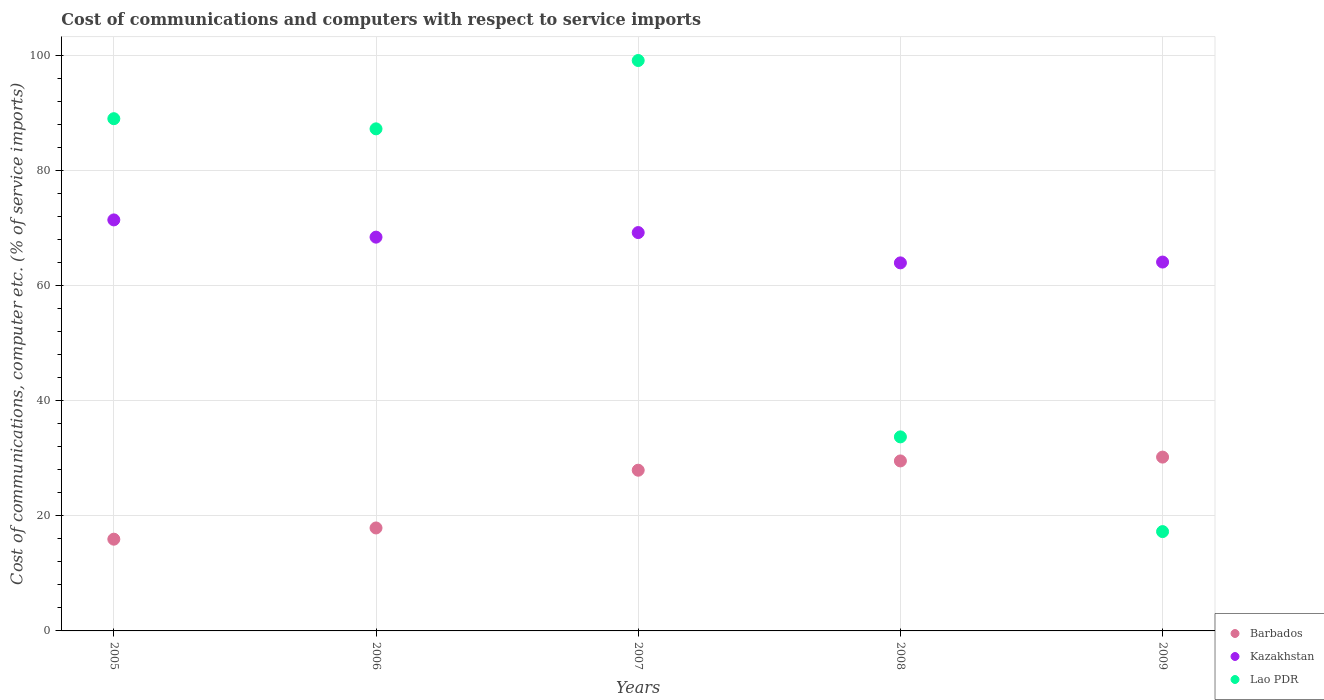Is the number of dotlines equal to the number of legend labels?
Your answer should be compact. Yes. What is the cost of communications and computers in Barbados in 2007?
Your answer should be compact. 27.93. Across all years, what is the maximum cost of communications and computers in Barbados?
Ensure brevity in your answer.  30.21. Across all years, what is the minimum cost of communications and computers in Barbados?
Offer a terse response. 15.94. In which year was the cost of communications and computers in Lao PDR maximum?
Provide a short and direct response. 2007. In which year was the cost of communications and computers in Lao PDR minimum?
Ensure brevity in your answer.  2009. What is the total cost of communications and computers in Lao PDR in the graph?
Your answer should be compact. 326.38. What is the difference between the cost of communications and computers in Kazakhstan in 2005 and that in 2006?
Offer a terse response. 3. What is the difference between the cost of communications and computers in Lao PDR in 2005 and the cost of communications and computers in Kazakhstan in 2007?
Your answer should be compact. 19.79. What is the average cost of communications and computers in Kazakhstan per year?
Your answer should be very brief. 67.43. In the year 2009, what is the difference between the cost of communications and computers in Kazakhstan and cost of communications and computers in Lao PDR?
Make the answer very short. 46.84. In how many years, is the cost of communications and computers in Barbados greater than 44 %?
Ensure brevity in your answer.  0. What is the ratio of the cost of communications and computers in Lao PDR in 2006 to that in 2009?
Ensure brevity in your answer.  5.05. What is the difference between the highest and the second highest cost of communications and computers in Lao PDR?
Give a very brief answer. 10.11. What is the difference between the highest and the lowest cost of communications and computers in Barbados?
Keep it short and to the point. 14.26. In how many years, is the cost of communications and computers in Kazakhstan greater than the average cost of communications and computers in Kazakhstan taken over all years?
Make the answer very short. 3. Is the sum of the cost of communications and computers in Lao PDR in 2006 and 2008 greater than the maximum cost of communications and computers in Barbados across all years?
Ensure brevity in your answer.  Yes. Is it the case that in every year, the sum of the cost of communications and computers in Kazakhstan and cost of communications and computers in Lao PDR  is greater than the cost of communications and computers in Barbados?
Make the answer very short. Yes. Is the cost of communications and computers in Kazakhstan strictly greater than the cost of communications and computers in Lao PDR over the years?
Your response must be concise. No. What is the difference between two consecutive major ticks on the Y-axis?
Give a very brief answer. 20. Does the graph contain grids?
Offer a terse response. Yes. How are the legend labels stacked?
Offer a terse response. Vertical. What is the title of the graph?
Provide a succinct answer. Cost of communications and computers with respect to service imports. Does "Germany" appear as one of the legend labels in the graph?
Keep it short and to the point. No. What is the label or title of the Y-axis?
Your answer should be compact. Cost of communications, computer etc. (% of service imports). What is the Cost of communications, computer etc. (% of service imports) of Barbados in 2005?
Provide a succinct answer. 15.94. What is the Cost of communications, computer etc. (% of service imports) of Kazakhstan in 2005?
Give a very brief answer. 71.43. What is the Cost of communications, computer etc. (% of service imports) of Lao PDR in 2005?
Offer a terse response. 89.02. What is the Cost of communications, computer etc. (% of service imports) of Barbados in 2006?
Provide a short and direct response. 17.89. What is the Cost of communications, computer etc. (% of service imports) in Kazakhstan in 2006?
Provide a succinct answer. 68.43. What is the Cost of communications, computer etc. (% of service imports) of Lao PDR in 2006?
Offer a terse response. 87.25. What is the Cost of communications, computer etc. (% of service imports) in Barbados in 2007?
Your answer should be very brief. 27.93. What is the Cost of communications, computer etc. (% of service imports) in Kazakhstan in 2007?
Keep it short and to the point. 69.23. What is the Cost of communications, computer etc. (% of service imports) in Lao PDR in 2007?
Keep it short and to the point. 99.13. What is the Cost of communications, computer etc. (% of service imports) of Barbados in 2008?
Offer a very short reply. 29.54. What is the Cost of communications, computer etc. (% of service imports) of Kazakhstan in 2008?
Make the answer very short. 63.96. What is the Cost of communications, computer etc. (% of service imports) in Lao PDR in 2008?
Provide a succinct answer. 33.72. What is the Cost of communications, computer etc. (% of service imports) of Barbados in 2009?
Offer a terse response. 30.21. What is the Cost of communications, computer etc. (% of service imports) of Kazakhstan in 2009?
Give a very brief answer. 64.1. What is the Cost of communications, computer etc. (% of service imports) of Lao PDR in 2009?
Offer a very short reply. 17.26. Across all years, what is the maximum Cost of communications, computer etc. (% of service imports) of Barbados?
Give a very brief answer. 30.21. Across all years, what is the maximum Cost of communications, computer etc. (% of service imports) in Kazakhstan?
Ensure brevity in your answer.  71.43. Across all years, what is the maximum Cost of communications, computer etc. (% of service imports) of Lao PDR?
Ensure brevity in your answer.  99.13. Across all years, what is the minimum Cost of communications, computer etc. (% of service imports) of Barbados?
Give a very brief answer. 15.94. Across all years, what is the minimum Cost of communications, computer etc. (% of service imports) of Kazakhstan?
Offer a very short reply. 63.96. Across all years, what is the minimum Cost of communications, computer etc. (% of service imports) in Lao PDR?
Offer a terse response. 17.26. What is the total Cost of communications, computer etc. (% of service imports) in Barbados in the graph?
Make the answer very short. 121.51. What is the total Cost of communications, computer etc. (% of service imports) of Kazakhstan in the graph?
Ensure brevity in your answer.  337.15. What is the total Cost of communications, computer etc. (% of service imports) of Lao PDR in the graph?
Keep it short and to the point. 326.38. What is the difference between the Cost of communications, computer etc. (% of service imports) of Barbados in 2005 and that in 2006?
Provide a short and direct response. -1.95. What is the difference between the Cost of communications, computer etc. (% of service imports) of Kazakhstan in 2005 and that in 2006?
Your answer should be very brief. 3. What is the difference between the Cost of communications, computer etc. (% of service imports) of Lao PDR in 2005 and that in 2006?
Make the answer very short. 1.77. What is the difference between the Cost of communications, computer etc. (% of service imports) in Barbados in 2005 and that in 2007?
Your answer should be very brief. -11.99. What is the difference between the Cost of communications, computer etc. (% of service imports) of Kazakhstan in 2005 and that in 2007?
Offer a very short reply. 2.2. What is the difference between the Cost of communications, computer etc. (% of service imports) in Lao PDR in 2005 and that in 2007?
Make the answer very short. -10.11. What is the difference between the Cost of communications, computer etc. (% of service imports) in Barbados in 2005 and that in 2008?
Ensure brevity in your answer.  -13.6. What is the difference between the Cost of communications, computer etc. (% of service imports) in Kazakhstan in 2005 and that in 2008?
Your answer should be compact. 7.47. What is the difference between the Cost of communications, computer etc. (% of service imports) in Lao PDR in 2005 and that in 2008?
Your answer should be compact. 55.3. What is the difference between the Cost of communications, computer etc. (% of service imports) of Barbados in 2005 and that in 2009?
Give a very brief answer. -14.26. What is the difference between the Cost of communications, computer etc. (% of service imports) in Kazakhstan in 2005 and that in 2009?
Give a very brief answer. 7.33. What is the difference between the Cost of communications, computer etc. (% of service imports) in Lao PDR in 2005 and that in 2009?
Give a very brief answer. 71.76. What is the difference between the Cost of communications, computer etc. (% of service imports) in Barbados in 2006 and that in 2007?
Make the answer very short. -10.03. What is the difference between the Cost of communications, computer etc. (% of service imports) of Kazakhstan in 2006 and that in 2007?
Your response must be concise. -0.8. What is the difference between the Cost of communications, computer etc. (% of service imports) of Lao PDR in 2006 and that in 2007?
Provide a short and direct response. -11.88. What is the difference between the Cost of communications, computer etc. (% of service imports) of Barbados in 2006 and that in 2008?
Your answer should be very brief. -11.65. What is the difference between the Cost of communications, computer etc. (% of service imports) of Kazakhstan in 2006 and that in 2008?
Ensure brevity in your answer.  4.47. What is the difference between the Cost of communications, computer etc. (% of service imports) of Lao PDR in 2006 and that in 2008?
Offer a very short reply. 53.53. What is the difference between the Cost of communications, computer etc. (% of service imports) in Barbados in 2006 and that in 2009?
Ensure brevity in your answer.  -12.31. What is the difference between the Cost of communications, computer etc. (% of service imports) in Kazakhstan in 2006 and that in 2009?
Your answer should be very brief. 4.33. What is the difference between the Cost of communications, computer etc. (% of service imports) of Lao PDR in 2006 and that in 2009?
Your response must be concise. 69.99. What is the difference between the Cost of communications, computer etc. (% of service imports) in Barbados in 2007 and that in 2008?
Offer a terse response. -1.61. What is the difference between the Cost of communications, computer etc. (% of service imports) of Kazakhstan in 2007 and that in 2008?
Keep it short and to the point. 5.27. What is the difference between the Cost of communications, computer etc. (% of service imports) in Lao PDR in 2007 and that in 2008?
Ensure brevity in your answer.  65.41. What is the difference between the Cost of communications, computer etc. (% of service imports) of Barbados in 2007 and that in 2009?
Provide a succinct answer. -2.28. What is the difference between the Cost of communications, computer etc. (% of service imports) of Kazakhstan in 2007 and that in 2009?
Give a very brief answer. 5.12. What is the difference between the Cost of communications, computer etc. (% of service imports) of Lao PDR in 2007 and that in 2009?
Your response must be concise. 81.87. What is the difference between the Cost of communications, computer etc. (% of service imports) in Barbados in 2008 and that in 2009?
Keep it short and to the point. -0.67. What is the difference between the Cost of communications, computer etc. (% of service imports) in Kazakhstan in 2008 and that in 2009?
Ensure brevity in your answer.  -0.14. What is the difference between the Cost of communications, computer etc. (% of service imports) of Lao PDR in 2008 and that in 2009?
Offer a very short reply. 16.46. What is the difference between the Cost of communications, computer etc. (% of service imports) of Barbados in 2005 and the Cost of communications, computer etc. (% of service imports) of Kazakhstan in 2006?
Provide a short and direct response. -52.49. What is the difference between the Cost of communications, computer etc. (% of service imports) of Barbados in 2005 and the Cost of communications, computer etc. (% of service imports) of Lao PDR in 2006?
Your response must be concise. -71.31. What is the difference between the Cost of communications, computer etc. (% of service imports) in Kazakhstan in 2005 and the Cost of communications, computer etc. (% of service imports) in Lao PDR in 2006?
Ensure brevity in your answer.  -15.83. What is the difference between the Cost of communications, computer etc. (% of service imports) in Barbados in 2005 and the Cost of communications, computer etc. (% of service imports) in Kazakhstan in 2007?
Ensure brevity in your answer.  -53.28. What is the difference between the Cost of communications, computer etc. (% of service imports) of Barbados in 2005 and the Cost of communications, computer etc. (% of service imports) of Lao PDR in 2007?
Provide a succinct answer. -83.19. What is the difference between the Cost of communications, computer etc. (% of service imports) in Kazakhstan in 2005 and the Cost of communications, computer etc. (% of service imports) in Lao PDR in 2007?
Your response must be concise. -27.7. What is the difference between the Cost of communications, computer etc. (% of service imports) of Barbados in 2005 and the Cost of communications, computer etc. (% of service imports) of Kazakhstan in 2008?
Your answer should be compact. -48.02. What is the difference between the Cost of communications, computer etc. (% of service imports) of Barbados in 2005 and the Cost of communications, computer etc. (% of service imports) of Lao PDR in 2008?
Keep it short and to the point. -17.78. What is the difference between the Cost of communications, computer etc. (% of service imports) of Kazakhstan in 2005 and the Cost of communications, computer etc. (% of service imports) of Lao PDR in 2008?
Offer a terse response. 37.71. What is the difference between the Cost of communications, computer etc. (% of service imports) of Barbados in 2005 and the Cost of communications, computer etc. (% of service imports) of Kazakhstan in 2009?
Your answer should be very brief. -48.16. What is the difference between the Cost of communications, computer etc. (% of service imports) of Barbados in 2005 and the Cost of communications, computer etc. (% of service imports) of Lao PDR in 2009?
Your answer should be very brief. -1.32. What is the difference between the Cost of communications, computer etc. (% of service imports) of Kazakhstan in 2005 and the Cost of communications, computer etc. (% of service imports) of Lao PDR in 2009?
Ensure brevity in your answer.  54.17. What is the difference between the Cost of communications, computer etc. (% of service imports) in Barbados in 2006 and the Cost of communications, computer etc. (% of service imports) in Kazakhstan in 2007?
Provide a succinct answer. -51.33. What is the difference between the Cost of communications, computer etc. (% of service imports) of Barbados in 2006 and the Cost of communications, computer etc. (% of service imports) of Lao PDR in 2007?
Your answer should be very brief. -81.24. What is the difference between the Cost of communications, computer etc. (% of service imports) in Kazakhstan in 2006 and the Cost of communications, computer etc. (% of service imports) in Lao PDR in 2007?
Give a very brief answer. -30.7. What is the difference between the Cost of communications, computer etc. (% of service imports) in Barbados in 2006 and the Cost of communications, computer etc. (% of service imports) in Kazakhstan in 2008?
Offer a terse response. -46.07. What is the difference between the Cost of communications, computer etc. (% of service imports) of Barbados in 2006 and the Cost of communications, computer etc. (% of service imports) of Lao PDR in 2008?
Your answer should be very brief. -15.83. What is the difference between the Cost of communications, computer etc. (% of service imports) in Kazakhstan in 2006 and the Cost of communications, computer etc. (% of service imports) in Lao PDR in 2008?
Give a very brief answer. 34.71. What is the difference between the Cost of communications, computer etc. (% of service imports) of Barbados in 2006 and the Cost of communications, computer etc. (% of service imports) of Kazakhstan in 2009?
Ensure brevity in your answer.  -46.21. What is the difference between the Cost of communications, computer etc. (% of service imports) of Barbados in 2006 and the Cost of communications, computer etc. (% of service imports) of Lao PDR in 2009?
Offer a very short reply. 0.63. What is the difference between the Cost of communications, computer etc. (% of service imports) in Kazakhstan in 2006 and the Cost of communications, computer etc. (% of service imports) in Lao PDR in 2009?
Offer a terse response. 51.17. What is the difference between the Cost of communications, computer etc. (% of service imports) of Barbados in 2007 and the Cost of communications, computer etc. (% of service imports) of Kazakhstan in 2008?
Give a very brief answer. -36.03. What is the difference between the Cost of communications, computer etc. (% of service imports) in Barbados in 2007 and the Cost of communications, computer etc. (% of service imports) in Lao PDR in 2008?
Provide a succinct answer. -5.79. What is the difference between the Cost of communications, computer etc. (% of service imports) in Kazakhstan in 2007 and the Cost of communications, computer etc. (% of service imports) in Lao PDR in 2008?
Make the answer very short. 35.51. What is the difference between the Cost of communications, computer etc. (% of service imports) in Barbados in 2007 and the Cost of communications, computer etc. (% of service imports) in Kazakhstan in 2009?
Provide a succinct answer. -36.17. What is the difference between the Cost of communications, computer etc. (% of service imports) of Barbados in 2007 and the Cost of communications, computer etc. (% of service imports) of Lao PDR in 2009?
Provide a short and direct response. 10.67. What is the difference between the Cost of communications, computer etc. (% of service imports) of Kazakhstan in 2007 and the Cost of communications, computer etc. (% of service imports) of Lao PDR in 2009?
Ensure brevity in your answer.  51.97. What is the difference between the Cost of communications, computer etc. (% of service imports) in Barbados in 2008 and the Cost of communications, computer etc. (% of service imports) in Kazakhstan in 2009?
Your answer should be very brief. -34.56. What is the difference between the Cost of communications, computer etc. (% of service imports) of Barbados in 2008 and the Cost of communications, computer etc. (% of service imports) of Lao PDR in 2009?
Offer a terse response. 12.28. What is the difference between the Cost of communications, computer etc. (% of service imports) in Kazakhstan in 2008 and the Cost of communications, computer etc. (% of service imports) in Lao PDR in 2009?
Your answer should be compact. 46.7. What is the average Cost of communications, computer etc. (% of service imports) in Barbados per year?
Offer a terse response. 24.3. What is the average Cost of communications, computer etc. (% of service imports) in Kazakhstan per year?
Provide a succinct answer. 67.43. What is the average Cost of communications, computer etc. (% of service imports) in Lao PDR per year?
Your answer should be compact. 65.28. In the year 2005, what is the difference between the Cost of communications, computer etc. (% of service imports) of Barbados and Cost of communications, computer etc. (% of service imports) of Kazakhstan?
Make the answer very short. -55.48. In the year 2005, what is the difference between the Cost of communications, computer etc. (% of service imports) of Barbados and Cost of communications, computer etc. (% of service imports) of Lao PDR?
Your response must be concise. -73.08. In the year 2005, what is the difference between the Cost of communications, computer etc. (% of service imports) in Kazakhstan and Cost of communications, computer etc. (% of service imports) in Lao PDR?
Ensure brevity in your answer.  -17.59. In the year 2006, what is the difference between the Cost of communications, computer etc. (% of service imports) of Barbados and Cost of communications, computer etc. (% of service imports) of Kazakhstan?
Ensure brevity in your answer.  -50.54. In the year 2006, what is the difference between the Cost of communications, computer etc. (% of service imports) of Barbados and Cost of communications, computer etc. (% of service imports) of Lao PDR?
Ensure brevity in your answer.  -69.36. In the year 2006, what is the difference between the Cost of communications, computer etc. (% of service imports) in Kazakhstan and Cost of communications, computer etc. (% of service imports) in Lao PDR?
Make the answer very short. -18.82. In the year 2007, what is the difference between the Cost of communications, computer etc. (% of service imports) in Barbados and Cost of communications, computer etc. (% of service imports) in Kazakhstan?
Your answer should be compact. -41.3. In the year 2007, what is the difference between the Cost of communications, computer etc. (% of service imports) in Barbados and Cost of communications, computer etc. (% of service imports) in Lao PDR?
Give a very brief answer. -71.2. In the year 2007, what is the difference between the Cost of communications, computer etc. (% of service imports) of Kazakhstan and Cost of communications, computer etc. (% of service imports) of Lao PDR?
Ensure brevity in your answer.  -29.9. In the year 2008, what is the difference between the Cost of communications, computer etc. (% of service imports) in Barbados and Cost of communications, computer etc. (% of service imports) in Kazakhstan?
Give a very brief answer. -34.42. In the year 2008, what is the difference between the Cost of communications, computer etc. (% of service imports) of Barbados and Cost of communications, computer etc. (% of service imports) of Lao PDR?
Offer a terse response. -4.18. In the year 2008, what is the difference between the Cost of communications, computer etc. (% of service imports) in Kazakhstan and Cost of communications, computer etc. (% of service imports) in Lao PDR?
Make the answer very short. 30.24. In the year 2009, what is the difference between the Cost of communications, computer etc. (% of service imports) in Barbados and Cost of communications, computer etc. (% of service imports) in Kazakhstan?
Your answer should be very brief. -33.9. In the year 2009, what is the difference between the Cost of communications, computer etc. (% of service imports) of Barbados and Cost of communications, computer etc. (% of service imports) of Lao PDR?
Your answer should be compact. 12.95. In the year 2009, what is the difference between the Cost of communications, computer etc. (% of service imports) in Kazakhstan and Cost of communications, computer etc. (% of service imports) in Lao PDR?
Your answer should be very brief. 46.84. What is the ratio of the Cost of communications, computer etc. (% of service imports) in Barbados in 2005 to that in 2006?
Your answer should be compact. 0.89. What is the ratio of the Cost of communications, computer etc. (% of service imports) in Kazakhstan in 2005 to that in 2006?
Ensure brevity in your answer.  1.04. What is the ratio of the Cost of communications, computer etc. (% of service imports) in Lao PDR in 2005 to that in 2006?
Make the answer very short. 1.02. What is the ratio of the Cost of communications, computer etc. (% of service imports) in Barbados in 2005 to that in 2007?
Ensure brevity in your answer.  0.57. What is the ratio of the Cost of communications, computer etc. (% of service imports) in Kazakhstan in 2005 to that in 2007?
Give a very brief answer. 1.03. What is the ratio of the Cost of communications, computer etc. (% of service imports) of Lao PDR in 2005 to that in 2007?
Provide a short and direct response. 0.9. What is the ratio of the Cost of communications, computer etc. (% of service imports) in Barbados in 2005 to that in 2008?
Your response must be concise. 0.54. What is the ratio of the Cost of communications, computer etc. (% of service imports) of Kazakhstan in 2005 to that in 2008?
Your response must be concise. 1.12. What is the ratio of the Cost of communications, computer etc. (% of service imports) in Lao PDR in 2005 to that in 2008?
Provide a short and direct response. 2.64. What is the ratio of the Cost of communications, computer etc. (% of service imports) of Barbados in 2005 to that in 2009?
Ensure brevity in your answer.  0.53. What is the ratio of the Cost of communications, computer etc. (% of service imports) of Kazakhstan in 2005 to that in 2009?
Provide a succinct answer. 1.11. What is the ratio of the Cost of communications, computer etc. (% of service imports) in Lao PDR in 2005 to that in 2009?
Your answer should be very brief. 5.16. What is the ratio of the Cost of communications, computer etc. (% of service imports) in Barbados in 2006 to that in 2007?
Your answer should be compact. 0.64. What is the ratio of the Cost of communications, computer etc. (% of service imports) of Lao PDR in 2006 to that in 2007?
Make the answer very short. 0.88. What is the ratio of the Cost of communications, computer etc. (% of service imports) of Barbados in 2006 to that in 2008?
Offer a very short reply. 0.61. What is the ratio of the Cost of communications, computer etc. (% of service imports) in Kazakhstan in 2006 to that in 2008?
Your answer should be compact. 1.07. What is the ratio of the Cost of communications, computer etc. (% of service imports) in Lao PDR in 2006 to that in 2008?
Provide a short and direct response. 2.59. What is the ratio of the Cost of communications, computer etc. (% of service imports) in Barbados in 2006 to that in 2009?
Offer a terse response. 0.59. What is the ratio of the Cost of communications, computer etc. (% of service imports) in Kazakhstan in 2006 to that in 2009?
Keep it short and to the point. 1.07. What is the ratio of the Cost of communications, computer etc. (% of service imports) of Lao PDR in 2006 to that in 2009?
Your answer should be compact. 5.05. What is the ratio of the Cost of communications, computer etc. (% of service imports) of Barbados in 2007 to that in 2008?
Provide a succinct answer. 0.95. What is the ratio of the Cost of communications, computer etc. (% of service imports) of Kazakhstan in 2007 to that in 2008?
Offer a terse response. 1.08. What is the ratio of the Cost of communications, computer etc. (% of service imports) in Lao PDR in 2007 to that in 2008?
Ensure brevity in your answer.  2.94. What is the ratio of the Cost of communications, computer etc. (% of service imports) of Barbados in 2007 to that in 2009?
Keep it short and to the point. 0.92. What is the ratio of the Cost of communications, computer etc. (% of service imports) of Kazakhstan in 2007 to that in 2009?
Keep it short and to the point. 1.08. What is the ratio of the Cost of communications, computer etc. (% of service imports) of Lao PDR in 2007 to that in 2009?
Your answer should be very brief. 5.74. What is the ratio of the Cost of communications, computer etc. (% of service imports) in Kazakhstan in 2008 to that in 2009?
Make the answer very short. 1. What is the ratio of the Cost of communications, computer etc. (% of service imports) in Lao PDR in 2008 to that in 2009?
Provide a short and direct response. 1.95. What is the difference between the highest and the second highest Cost of communications, computer etc. (% of service imports) of Barbados?
Your response must be concise. 0.67. What is the difference between the highest and the second highest Cost of communications, computer etc. (% of service imports) in Kazakhstan?
Ensure brevity in your answer.  2.2. What is the difference between the highest and the second highest Cost of communications, computer etc. (% of service imports) in Lao PDR?
Give a very brief answer. 10.11. What is the difference between the highest and the lowest Cost of communications, computer etc. (% of service imports) of Barbados?
Offer a very short reply. 14.26. What is the difference between the highest and the lowest Cost of communications, computer etc. (% of service imports) of Kazakhstan?
Keep it short and to the point. 7.47. What is the difference between the highest and the lowest Cost of communications, computer etc. (% of service imports) in Lao PDR?
Make the answer very short. 81.87. 